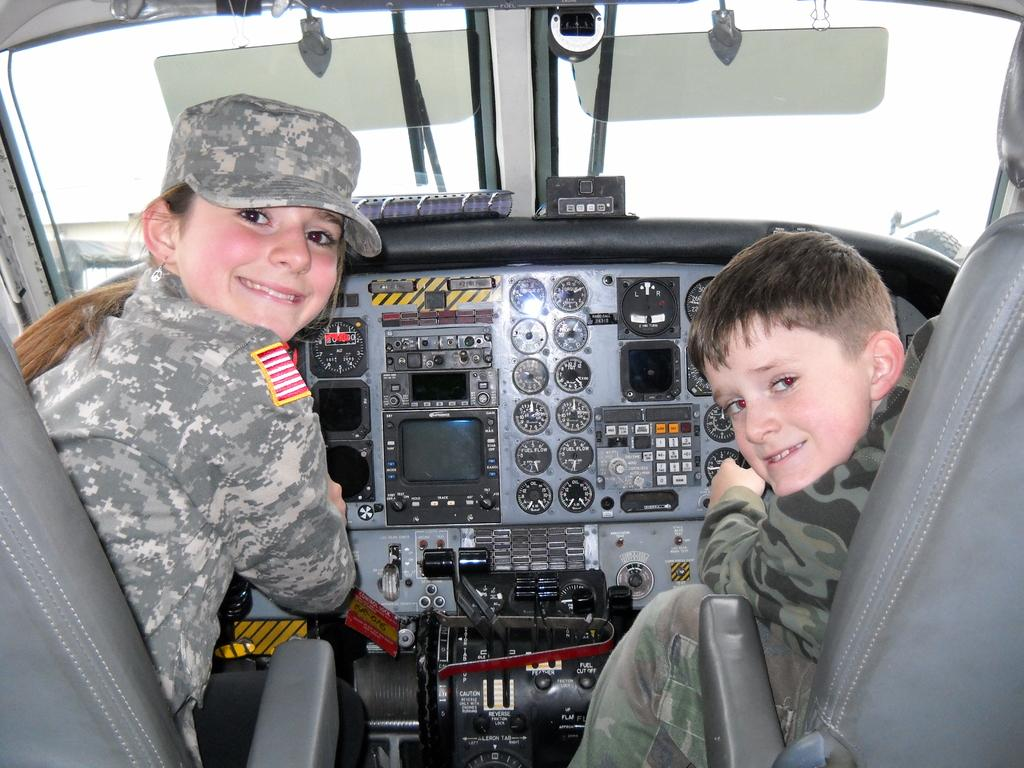What is the setting of the image? The image shows the inside view of a vehicle. Who is present in the vehicle? There is a girl and a boy in the vehicle. What are the girl and boy doing in the image? The girl and boy are sitting on seats inside the vehicle. What type of instruments are present inside the vehicle? There are meters and buttons inside the vehicle. Are there any other objects visible inside the vehicle? Yes, there are other objects inside the vehicle. What type of caption is written on the girl's foot in the image? There is no caption written on the girl's foot in the image, as the image does not show any text or writing on her foot. 